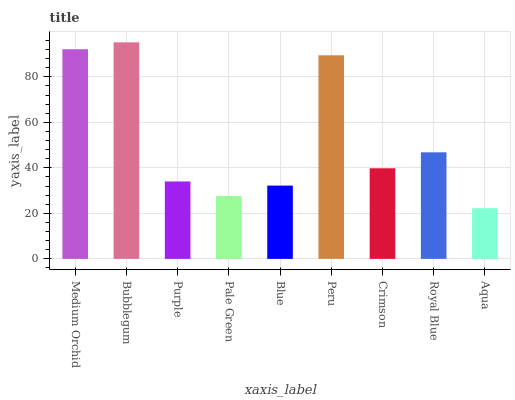Is Aqua the minimum?
Answer yes or no. Yes. Is Bubblegum the maximum?
Answer yes or no. Yes. Is Purple the minimum?
Answer yes or no. No. Is Purple the maximum?
Answer yes or no. No. Is Bubblegum greater than Purple?
Answer yes or no. Yes. Is Purple less than Bubblegum?
Answer yes or no. Yes. Is Purple greater than Bubblegum?
Answer yes or no. No. Is Bubblegum less than Purple?
Answer yes or no. No. Is Crimson the high median?
Answer yes or no. Yes. Is Crimson the low median?
Answer yes or no. Yes. Is Royal Blue the high median?
Answer yes or no. No. Is Blue the low median?
Answer yes or no. No. 